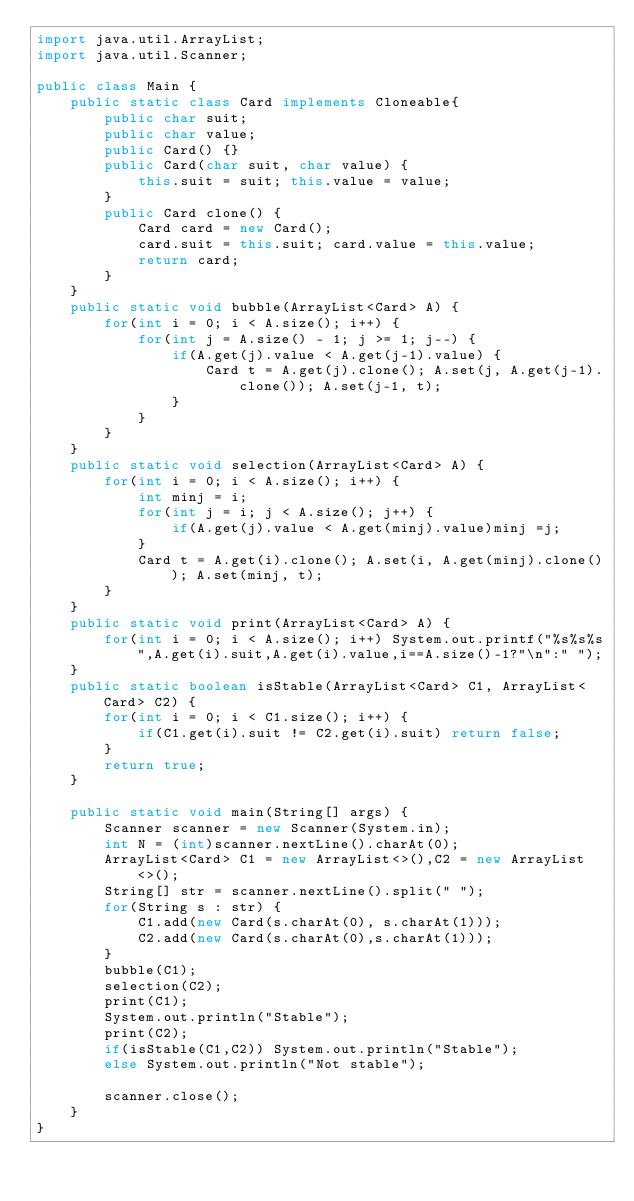<code> <loc_0><loc_0><loc_500><loc_500><_Java_>import java.util.ArrayList;
import java.util.Scanner;

public class Main {
	public static class Card implements Cloneable{
		public char suit;
		public char value;
		public Card() {}
		public Card(char suit, char value) {
			this.suit = suit; this.value = value;
		}
		public Card clone() {
			Card card = new Card();
			card.suit = this.suit; card.value = this.value;
			return card;
		}
	}
	public static void bubble(ArrayList<Card> A) {
		for(int i = 0; i < A.size(); i++) {
			for(int j = A.size() - 1; j >= 1; j--) {
				if(A.get(j).value < A.get(j-1).value) {
					Card t = A.get(j).clone(); A.set(j, A.get(j-1).clone()); A.set(j-1, t);
				}
			}
		}
	}
	public static void selection(ArrayList<Card> A) {
		for(int i = 0; i < A.size(); i++) {
			int minj = i;
			for(int j = i; j < A.size(); j++) {
				if(A.get(j).value < A.get(minj).value)minj =j;
			}
			Card t = A.get(i).clone(); A.set(i, A.get(minj).clone()); A.set(minj, t);
		}
	}
	public static void print(ArrayList<Card> A) {
		for(int i = 0; i < A.size(); i++) System.out.printf("%s%s%s",A.get(i).suit,A.get(i).value,i==A.size()-1?"\n":" ");
	}
	public static boolean isStable(ArrayList<Card> C1, ArrayList<Card> C2) {
		for(int i = 0; i < C1.size(); i++) {
			if(C1.get(i).suit != C2.get(i).suit) return false;
		}
		return true;
	}

	public static void main(String[] args) {
		Scanner scanner = new Scanner(System.in);
		int N = (int)scanner.nextLine().charAt(0);
		ArrayList<Card> C1 = new ArrayList<>(),C2 = new ArrayList<>();
		String[] str = scanner.nextLine().split(" ");
		for(String s : str) {
			C1.add(new Card(s.charAt(0), s.charAt(1)));
			C2.add(new Card(s.charAt(0),s.charAt(1)));
		}
		bubble(C1);
		selection(C2);
		print(C1);
		System.out.println("Stable");
		print(C2);
		if(isStable(C1,C2)) System.out.println("Stable");
		else System.out.println("Not stable");

		scanner.close();
	}
}
</code> 